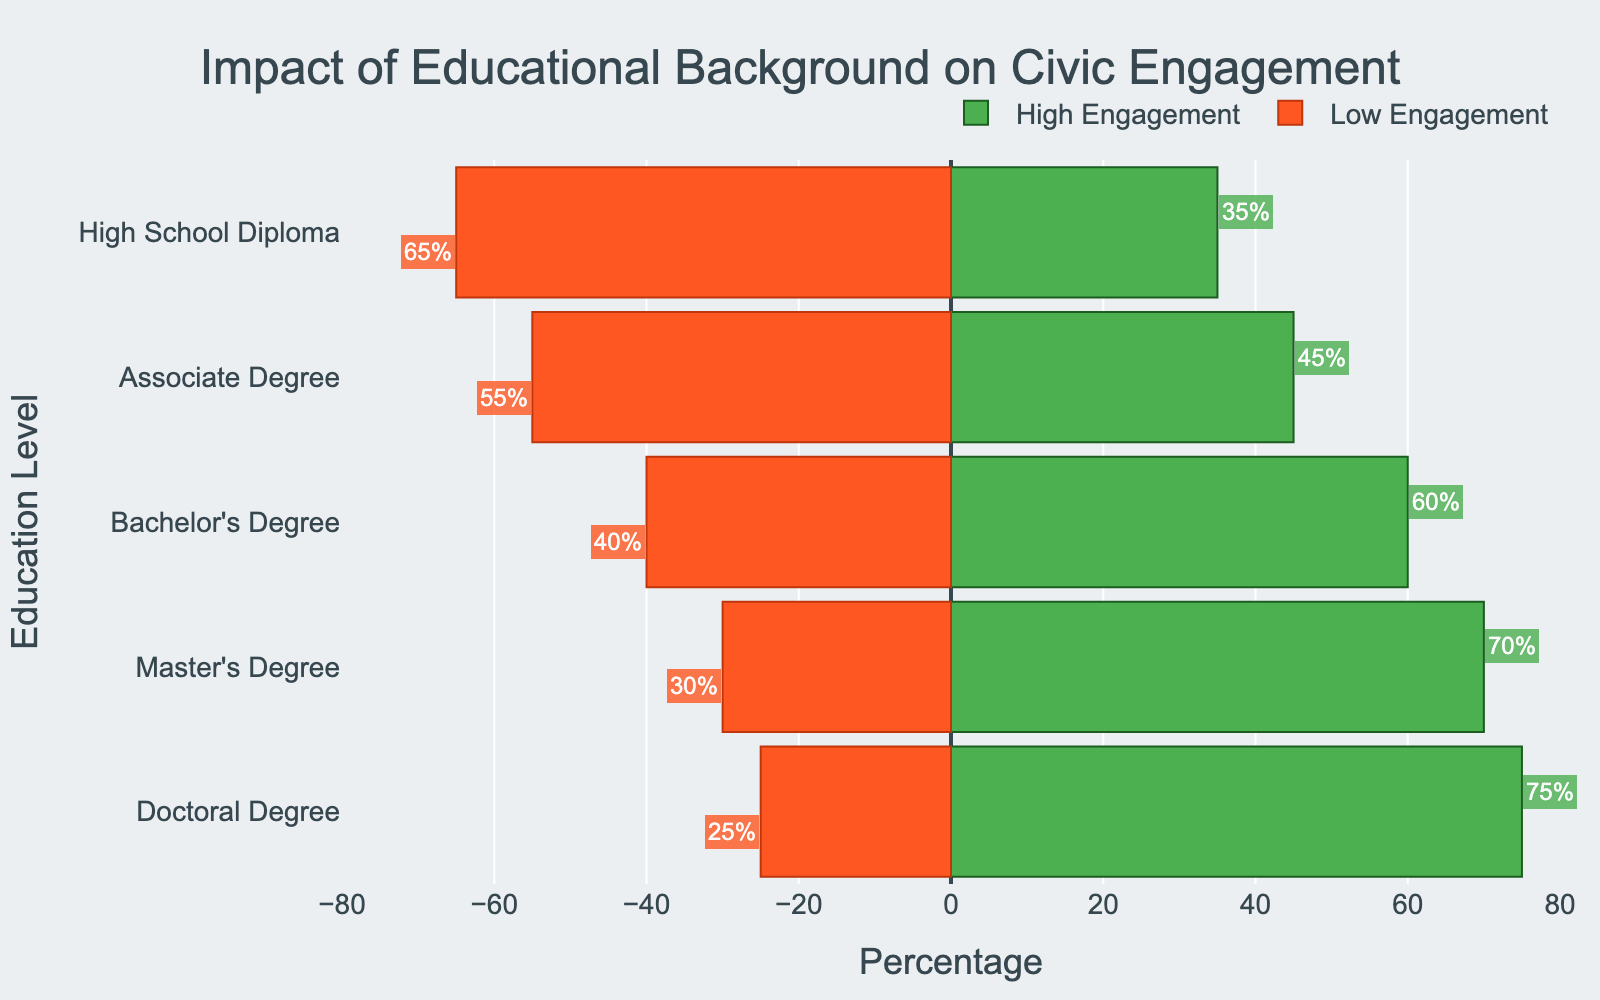What education level has the highest high-engagement percentage? The highest high-engagement percentage is shown by the longest green bar. The longest green bar belongs to the Doctoral Degree category with a high-engagement percentage of 75%.
Answer: Doctoral Degree What education level has the highest low-engagement percentage? The highest low-engagement percentage is indicated by the longest red bar. The longest red bar belongs to the High School Diploma category with a low-engagement percentage of 65%.
Answer: High School Diploma Which education level shows a high-engagement percentage of 45%? Identify the green bar with a length corresponding to 45% and then check its associated education level. The Associate Degree category has a 45% high-engagement percentage.
Answer: Associate Degree Compare the high-engagement percentages between Bachelor's Degree and Master's Degree holders. Which group is more engaged? Look at the lengths of the green bars for Bachelor's Degree and Master's Degree, and compare their values. The green bar for the Master's Degree (70%) is longer than that for the Bachelor's Degree (60%). Therefore, Master's Degree holders are more engaged.
Answer: Master's Degree What is the difference in low-engagement percentages between Associate Degree and Doctoral Degree holders? Compare the lengths of the red bars for Associate Degree (55%) and Doctoral Degree holders (25%). The difference is 55% - 25% = 30%.
Answer: 30% Which education level has an equal number of high and low engagement percentages? Find the education level where the lengths of green and red bars are equal. None of the levels have equal high and low engagement percentages.
Answer: None If you sum the high-engagement percentages for Bachelor's Degree and Master's Degree holders, what total do you get? Add the high-engagement percentages of Bachelor's Degree (60%) and Master's Degree (70%). 60% + 70% = 130%.
Answer: 130% Which group has a higher low-engagement percentage than high-engagement percentage, and by how much? Find the groups where the red bar is longer than the green bar and calculate the difference for each. High School Diploma has 65% low-engagement and 35% high-engagement. The difference is 65% - 35% = 30%. Similarly, Associate Degree has 55% low-engagement and 45% high-engagement. The difference is 55% - 45% = 10%.
Answer: High School Diploma by 30% and Associate Degree by 10% Identify the education level with the smallest low-engagement percentage. The shortest red bar indicates the smallest low-engagement percentage. The Doctoral Degree category has the shortest red bar with a low-engagement percentage of 25%.
Answer: Doctoral Degree What is the combined high- and low-engagement percentage for High School Diploma holders? The combined percentage is the sum of high-engagement and low-engagement percentages for High School Diploma holders. 35% (high) + 65% (low) = 100%.
Answer: 100% 